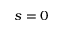<formula> <loc_0><loc_0><loc_500><loc_500>s = 0</formula> 